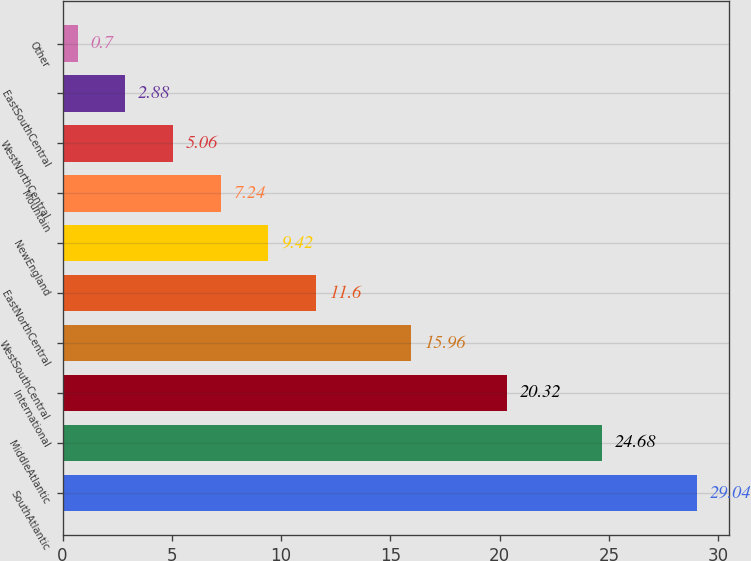Convert chart. <chart><loc_0><loc_0><loc_500><loc_500><bar_chart><fcel>SouthAtlantic<fcel>MiddleAtlantic<fcel>International<fcel>WestSouthCentral<fcel>EastNorthCentral<fcel>NewEngland<fcel>Mountain<fcel>WestNorthCentral<fcel>EastSouthCentral<fcel>Other<nl><fcel>29.04<fcel>24.68<fcel>20.32<fcel>15.96<fcel>11.6<fcel>9.42<fcel>7.24<fcel>5.06<fcel>2.88<fcel>0.7<nl></chart> 